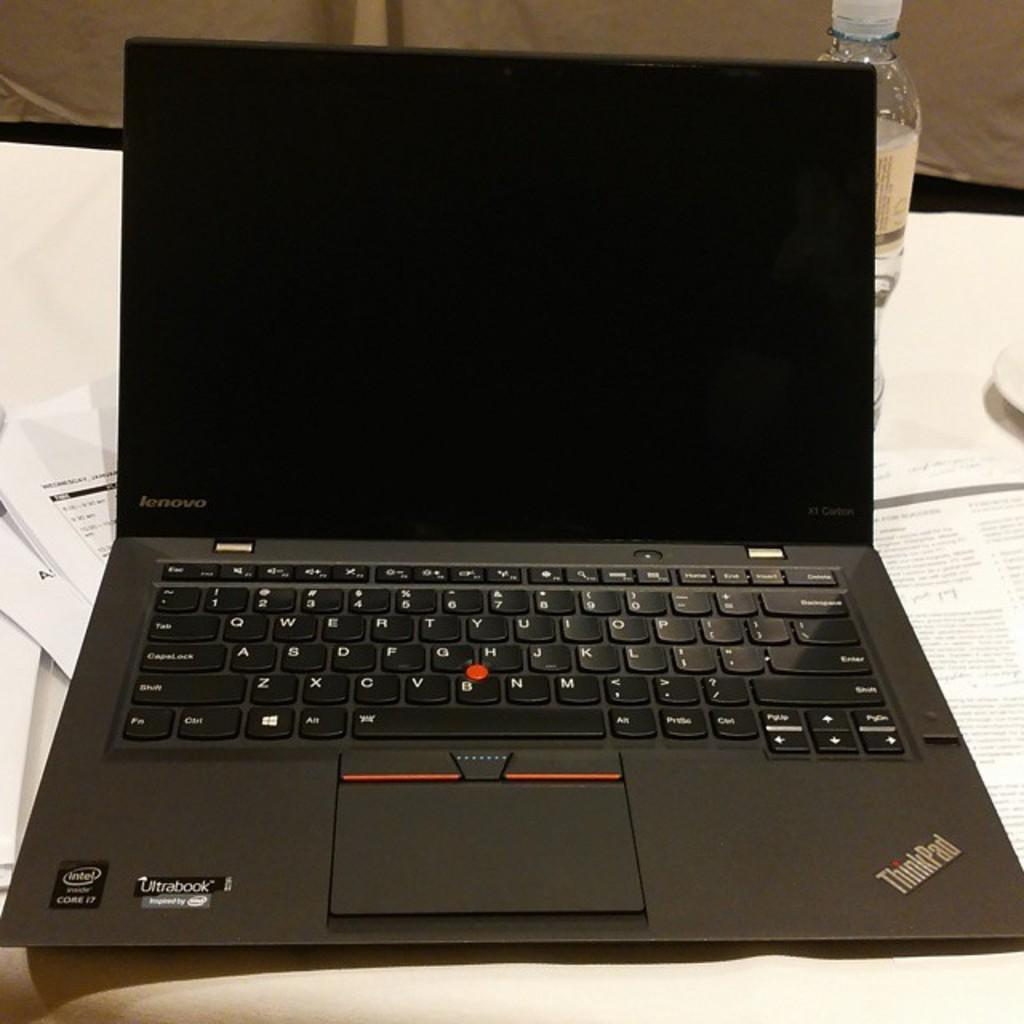Provide a one-sentence caption for the provided image. A computer is open with the ThinkPad logo in the corner. 